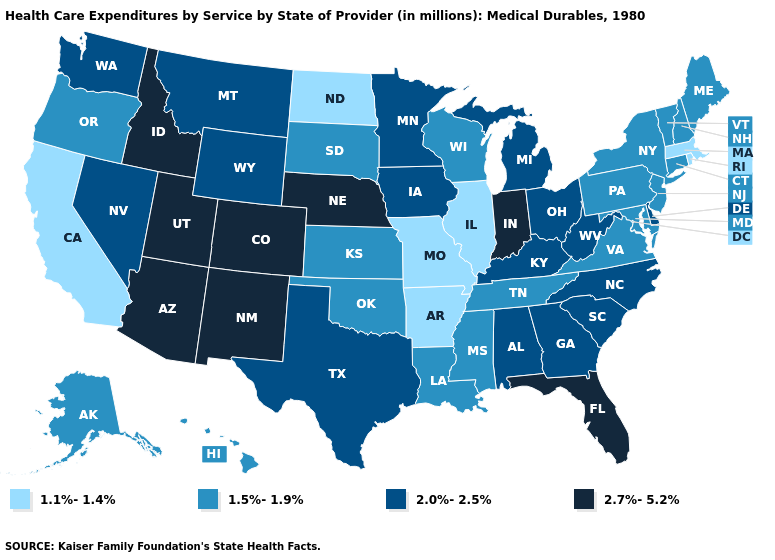Does Iowa have a lower value than Pennsylvania?
Answer briefly. No. Does Connecticut have the lowest value in the USA?
Concise answer only. No. Does the map have missing data?
Keep it brief. No. Does the map have missing data?
Quick response, please. No. Name the states that have a value in the range 2.7%-5.2%?
Keep it brief. Arizona, Colorado, Florida, Idaho, Indiana, Nebraska, New Mexico, Utah. Does Maryland have the lowest value in the South?
Be succinct. No. Which states have the lowest value in the Northeast?
Quick response, please. Massachusetts, Rhode Island. What is the value of Rhode Island?
Keep it brief. 1.1%-1.4%. Among the states that border Georgia , does South Carolina have the highest value?
Answer briefly. No. What is the highest value in states that border Mississippi?
Keep it brief. 2.0%-2.5%. Name the states that have a value in the range 1.5%-1.9%?
Answer briefly. Alaska, Connecticut, Hawaii, Kansas, Louisiana, Maine, Maryland, Mississippi, New Hampshire, New Jersey, New York, Oklahoma, Oregon, Pennsylvania, South Dakota, Tennessee, Vermont, Virginia, Wisconsin. What is the value of Ohio?
Answer briefly. 2.0%-2.5%. What is the value of North Dakota?
Concise answer only. 1.1%-1.4%. What is the value of Pennsylvania?
Keep it brief. 1.5%-1.9%. Which states have the lowest value in the Northeast?
Answer briefly. Massachusetts, Rhode Island. 